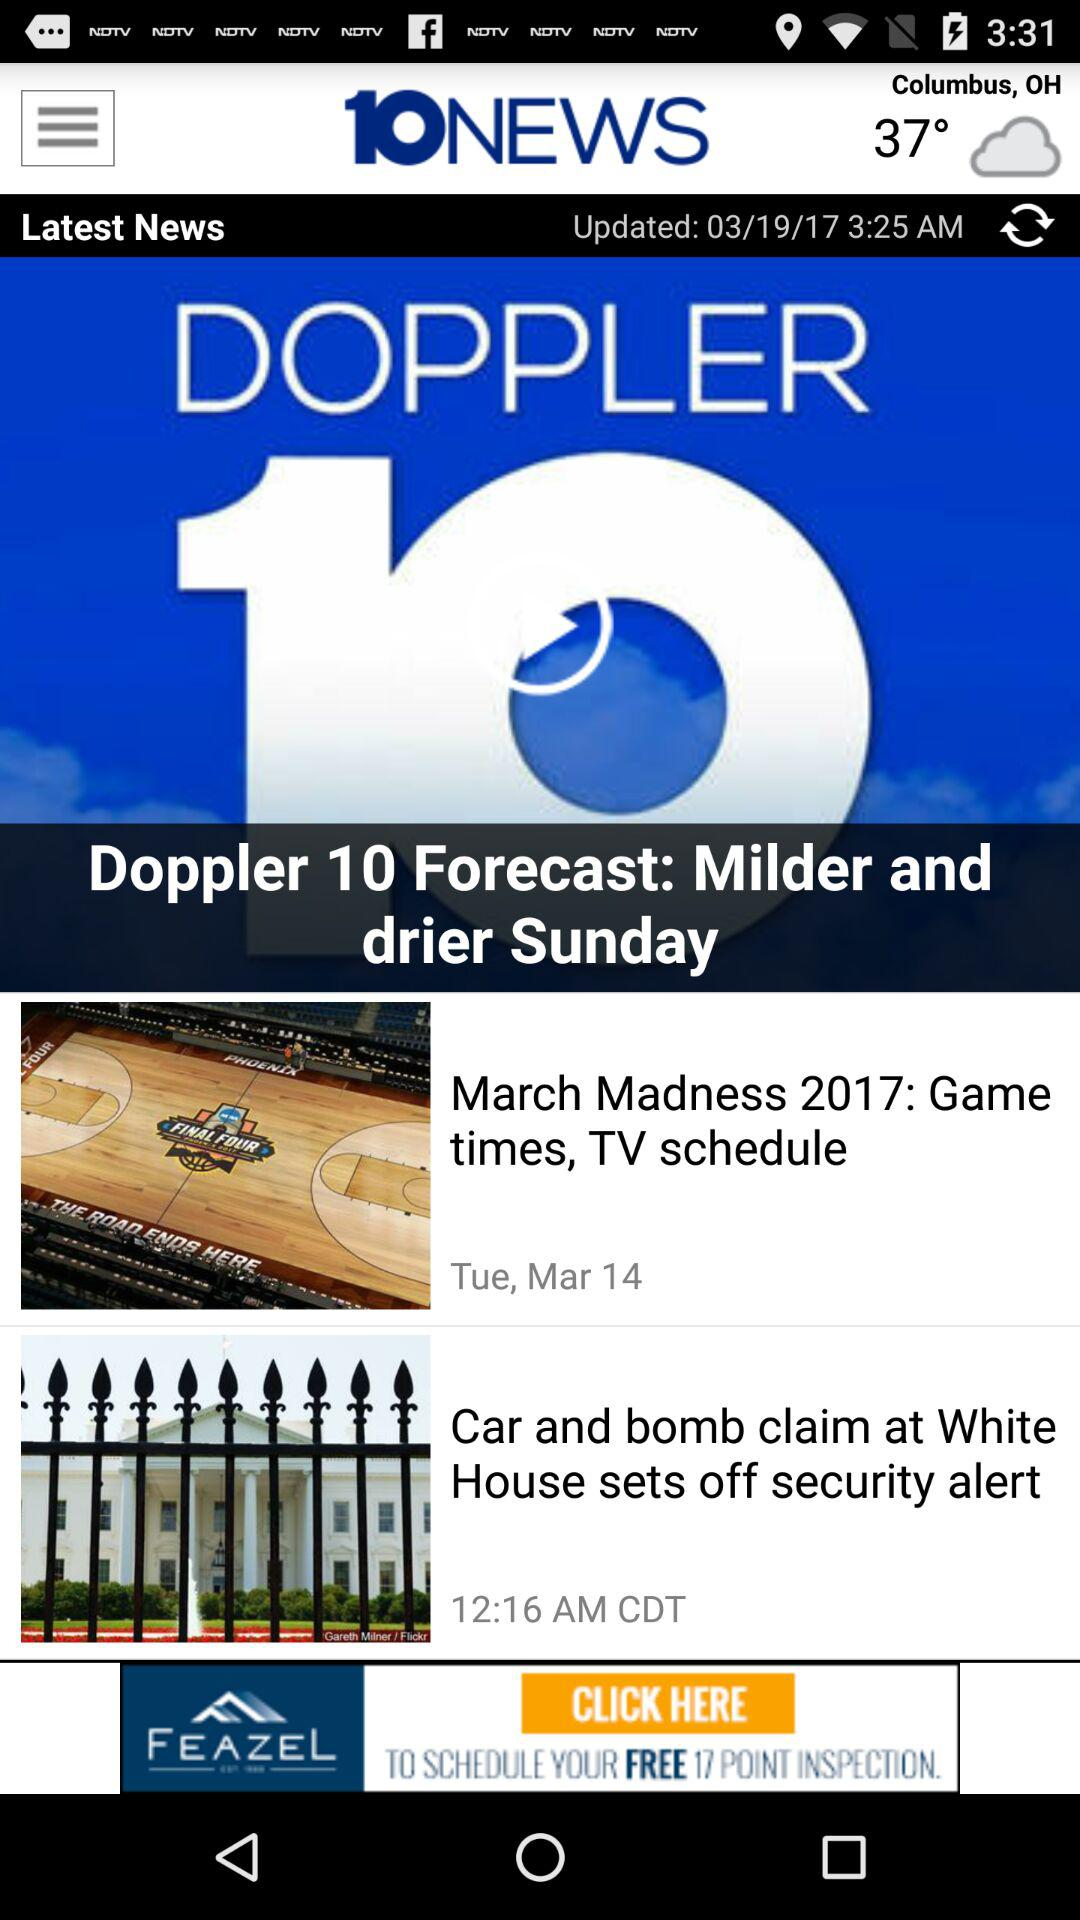When was the news last updated? The news was last updated on March 19, 2017 at 3:25 a.m. 